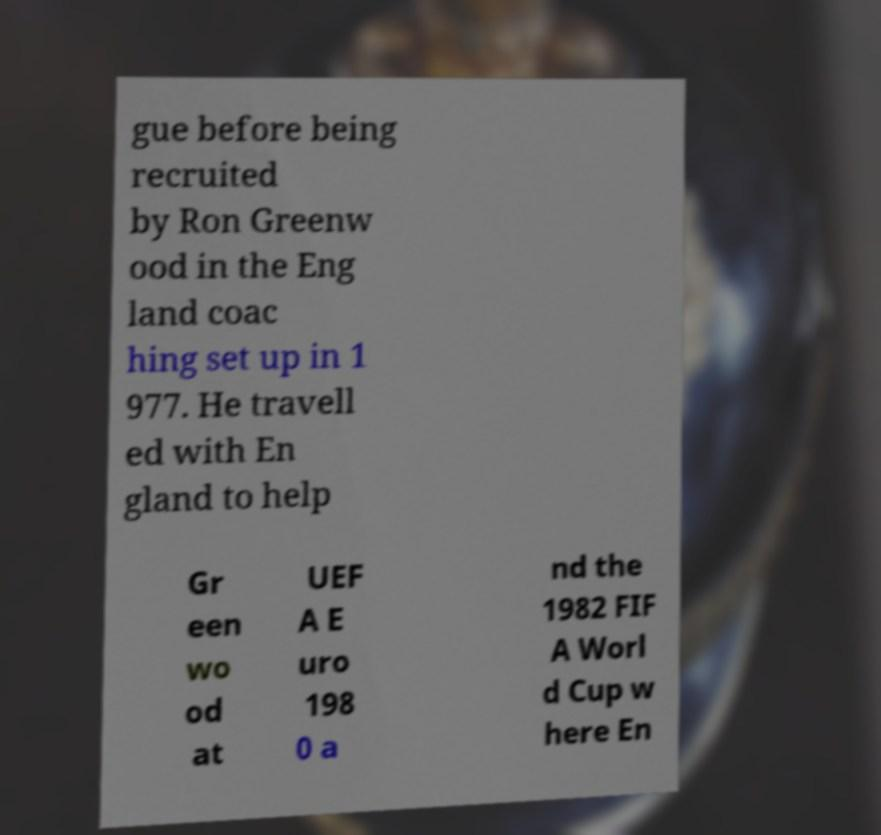Could you extract and type out the text from this image? gue before being recruited by Ron Greenw ood in the Eng land coac hing set up in 1 977. He travell ed with En gland to help Gr een wo od at UEF A E uro 198 0 a nd the 1982 FIF A Worl d Cup w here En 